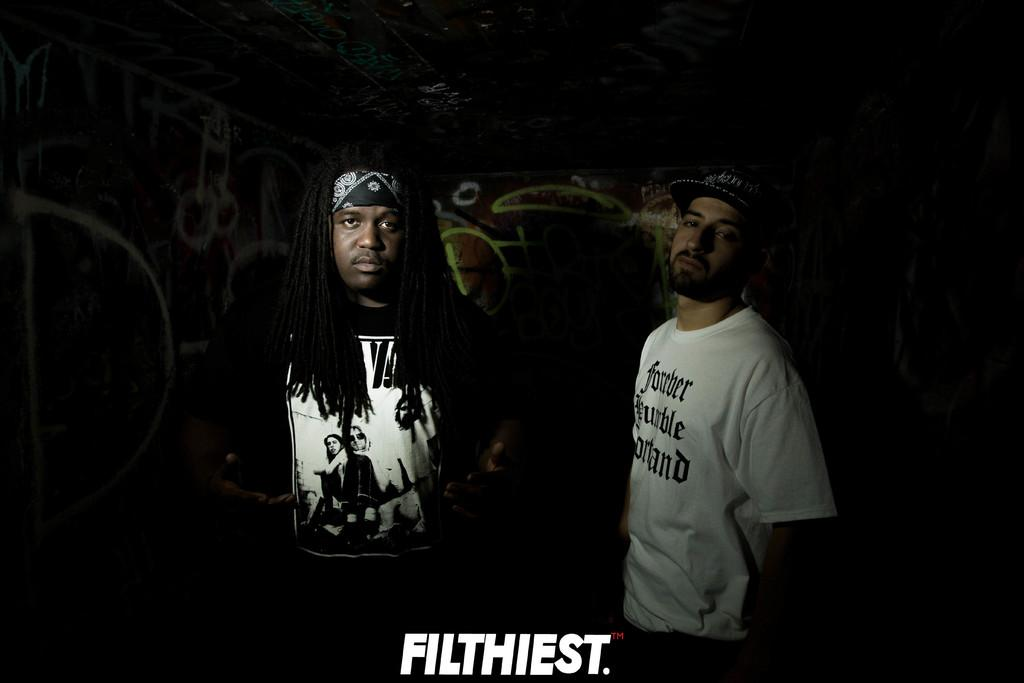How many men are in the image? There are two men in the image. Can you describe the clothing of the first man? The first man is wearing a white t-shirt and a cap. What is the second man wearing? The second man is wearing a black t-shirt. Is there any text or marking at the bottom of the image? Yes, a watermark is present at the bottom of the image. What type of goat can be seen smashing the fiction books in the image? There is no goat or fiction books present in the image. What genre of fiction books might the goat be smashing in the image? Since there are no fiction books or a goat in the image, it is impossible to determine the genre of any books that might be smashed. 